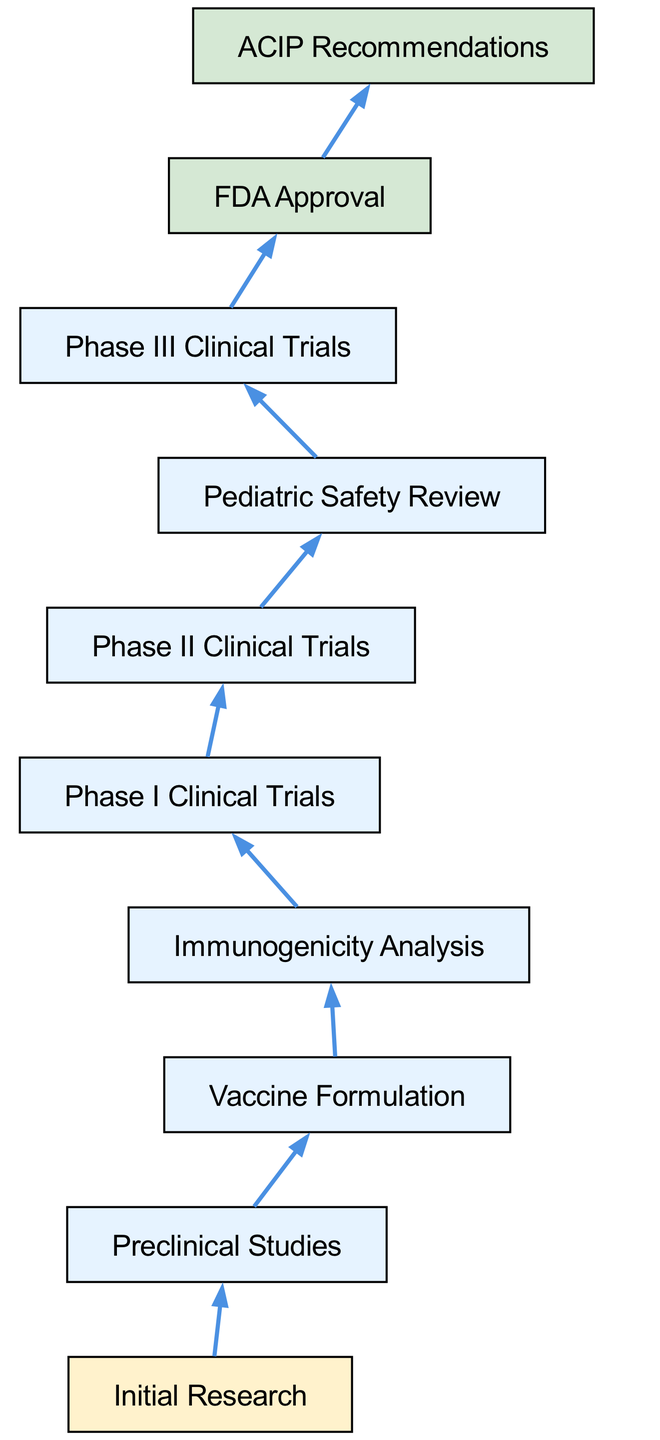What is the final step in the vaccine development process? The final step in the vaccine development process is the FDA Approval, which is indicated as the last node in the diagram.
Answer: FDA Approval How many phases of clinical trials are there in the vaccine development process? There are three phases of clinical trials outlined in the diagram: Phase I, Phase II, and Phase III.
Answer: Three What type of analysis follows Vaccine Formulation? After Vaccine Formulation, the next step is Immunogenicity Analysis, as shown in the flow of the diagram.
Answer: Immunogenicity Analysis Which step follows Initial Research? Preclinical Studies is the next step that follows Initial Research in the vaccine development process.
Answer: Preclinical Studies What recommendation is provided at the final stage of the vaccine development process? The final stage of the vaccine development process results in ACIP Recommendations, which is connected to the final step of FDA Approval in the diagram.
Answer: ACIP Recommendations How does Pediatric Safety Review relate to Phase III Clinical Trials? Pediatric Safety Review follows Phase III Clinical Trials as it is an important step to ensure the safety of the vaccine for children, making it a critical component of the overall development process shown in the diagram.
Answer: It follows How many connections are represented in the diagram? The diagram includes a total of eight connections representing the flow from one step to another in the vaccine development process.
Answer: Eight Which step involves the testing of vaccine safety before clinical trials? The step that involves testing the vaccine’s safety before clinical trials is Preclinical Studies, as outlined at the beginning of the process in the diagram.
Answer: Preclinical Studies What is the purpose of Immunogenicity Analysis in the flow? The purpose of Immunogenicity Analysis is to assess the immune response generated by the vaccine formulation, and it directly follows Vaccine Formulation as indicated in the diagram.
Answer: Assess immune response 